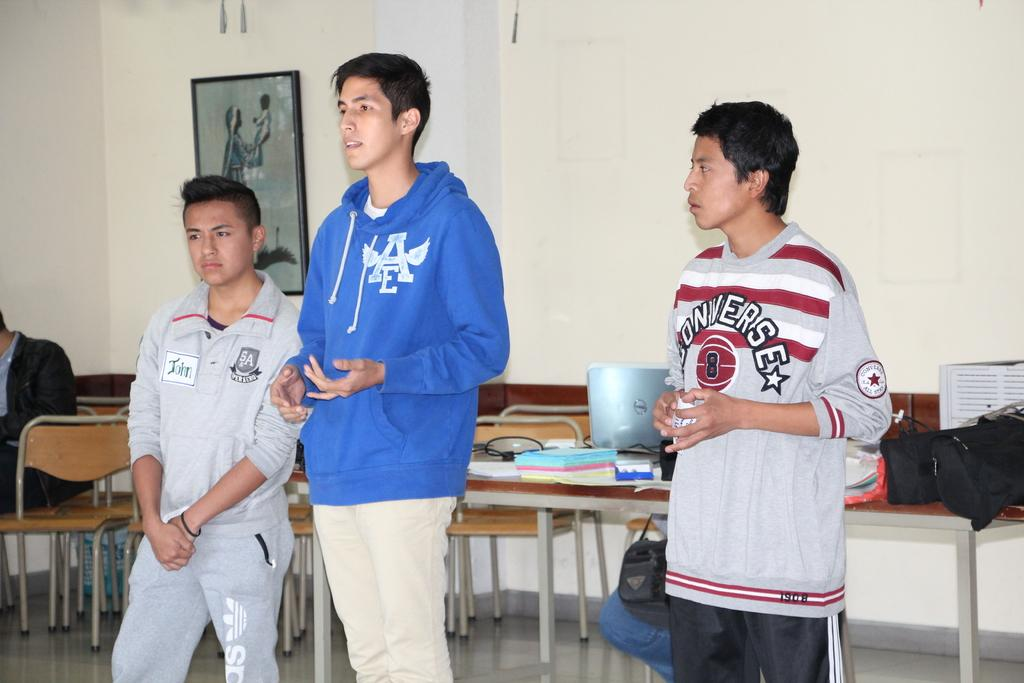<image>
Write a terse but informative summary of the picture. three males in a classroom with one wearing a Converse shirt 